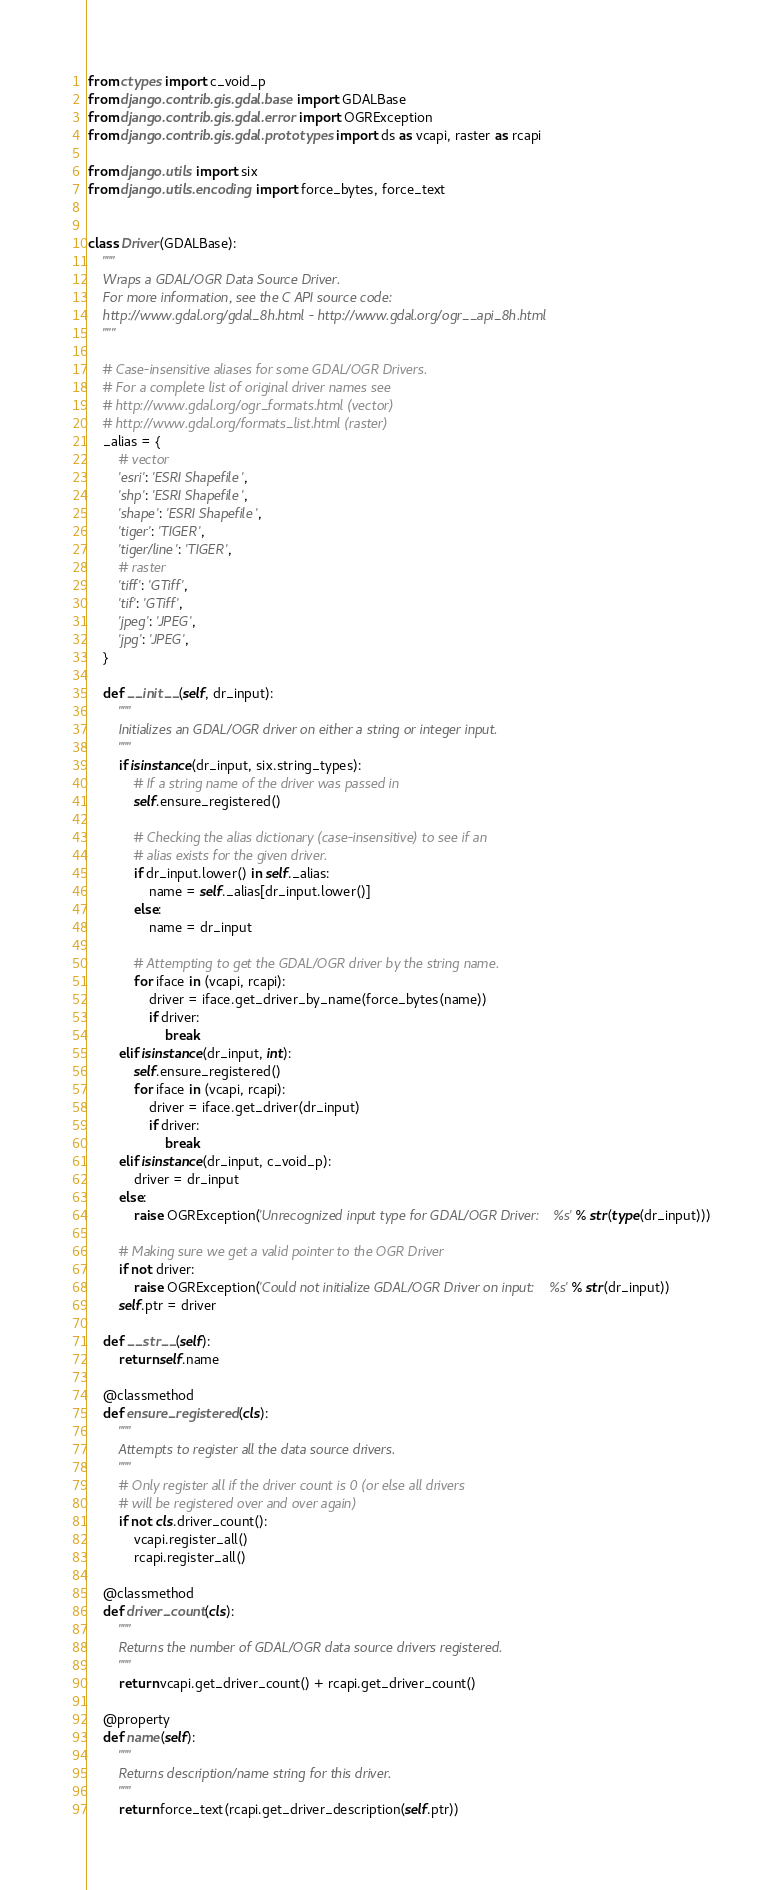<code> <loc_0><loc_0><loc_500><loc_500><_Python_>from ctypes import c_void_p
from django.contrib.gis.gdal.base import GDALBase
from django.contrib.gis.gdal.error import OGRException
from django.contrib.gis.gdal.prototypes import ds as vcapi, raster as rcapi

from django.utils import six
from django.utils.encoding import force_bytes, force_text


class Driver(GDALBase):
    """
    Wraps a GDAL/OGR Data Source Driver.
    For more information, see the C API source code:
    http://www.gdal.org/gdal_8h.html - http://www.gdal.org/ogr__api_8h.html
    """

    # Case-insensitive aliases for some GDAL/OGR Drivers.
    # For a complete list of original driver names see
    # http://www.gdal.org/ogr_formats.html (vector)
    # http://www.gdal.org/formats_list.html (raster)
    _alias = {
        # vector
        'esri': 'ESRI Shapefile',
        'shp': 'ESRI Shapefile',
        'shape': 'ESRI Shapefile',
        'tiger': 'TIGER',
        'tiger/line': 'TIGER',
        # raster
        'tiff': 'GTiff',
        'tif': 'GTiff',
        'jpeg': 'JPEG',
        'jpg': 'JPEG',
    }

    def __init__(self, dr_input):
        """
        Initializes an GDAL/OGR driver on either a string or integer input.
        """
        if isinstance(dr_input, six.string_types):
            # If a string name of the driver was passed in
            self.ensure_registered()

            # Checking the alias dictionary (case-insensitive) to see if an
            # alias exists for the given driver.
            if dr_input.lower() in self._alias:
                name = self._alias[dr_input.lower()]
            else:
                name = dr_input

            # Attempting to get the GDAL/OGR driver by the string name.
            for iface in (vcapi, rcapi):
                driver = iface.get_driver_by_name(force_bytes(name))
                if driver:
                    break
        elif isinstance(dr_input, int):
            self.ensure_registered()
            for iface in (vcapi, rcapi):
                driver = iface.get_driver(dr_input)
                if driver:
                    break
        elif isinstance(dr_input, c_void_p):
            driver = dr_input
        else:
            raise OGRException('Unrecognized input type for GDAL/OGR Driver: %s' % str(type(dr_input)))

        # Making sure we get a valid pointer to the OGR Driver
        if not driver:
            raise OGRException('Could not initialize GDAL/OGR Driver on input: %s' % str(dr_input))
        self.ptr = driver

    def __str__(self):
        return self.name

    @classmethod
    def ensure_registered(cls):
        """
        Attempts to register all the data source drivers.
        """
        # Only register all if the driver count is 0 (or else all drivers
        # will be registered over and over again)
        if not cls.driver_count():
            vcapi.register_all()
            rcapi.register_all()

    @classmethod
    def driver_count(cls):
        """
        Returns the number of GDAL/OGR data source drivers registered.
        """
        return vcapi.get_driver_count() + rcapi.get_driver_count()

    @property
    def name(self):
        """
        Returns description/name string for this driver.
        """
        return force_text(rcapi.get_driver_description(self.ptr))
</code> 